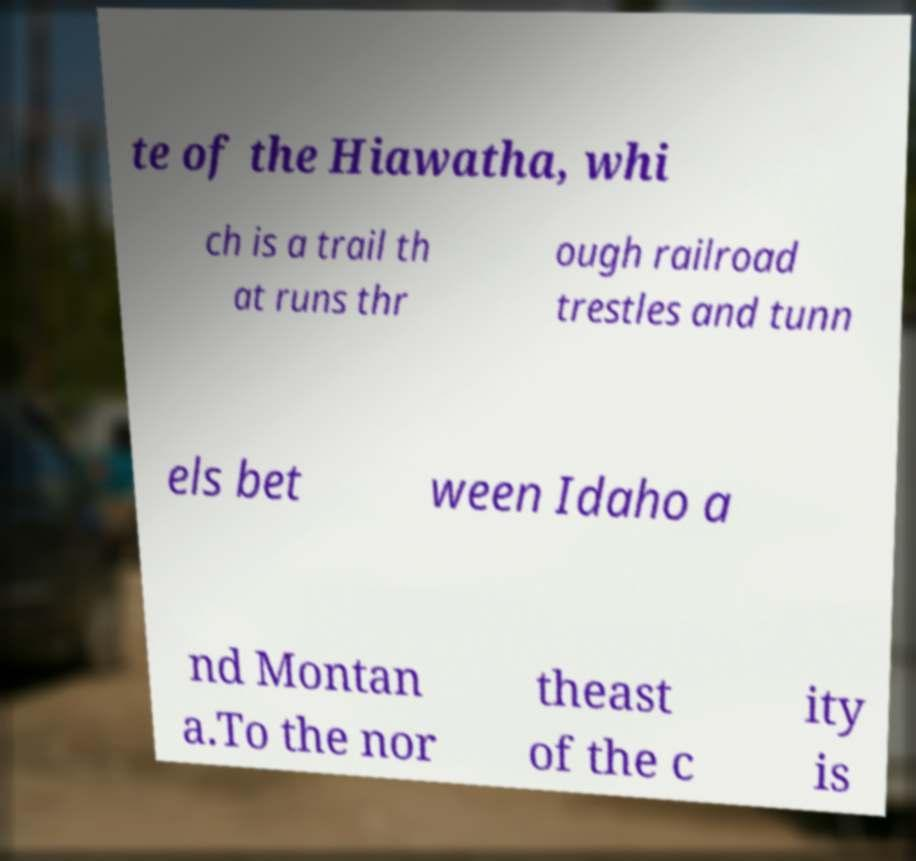Can you read and provide the text displayed in the image?This photo seems to have some interesting text. Can you extract and type it out for me? te of the Hiawatha, whi ch is a trail th at runs thr ough railroad trestles and tunn els bet ween Idaho a nd Montan a.To the nor theast of the c ity is 